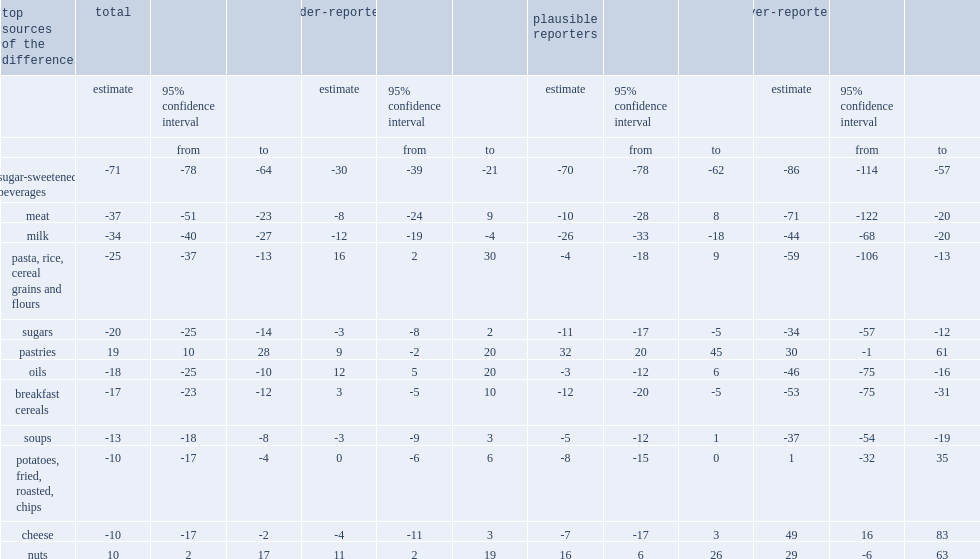List sources of the difference that have lower estimated energy intake in 2015 than in 2004, regardless of the category of reporters. Sugar-sweetened beverages milk. 